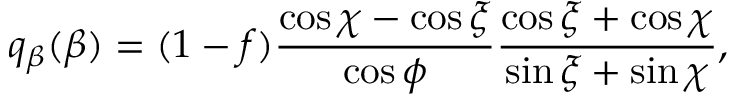<formula> <loc_0><loc_0><loc_500><loc_500>q _ { \beta } ( \beta ) = ( 1 - f ) \frac { \cos \chi - \cos \xi } { \cos \phi } \frac { \cos \xi + \cos \chi } { \sin \xi + \sin \chi } ,</formula> 